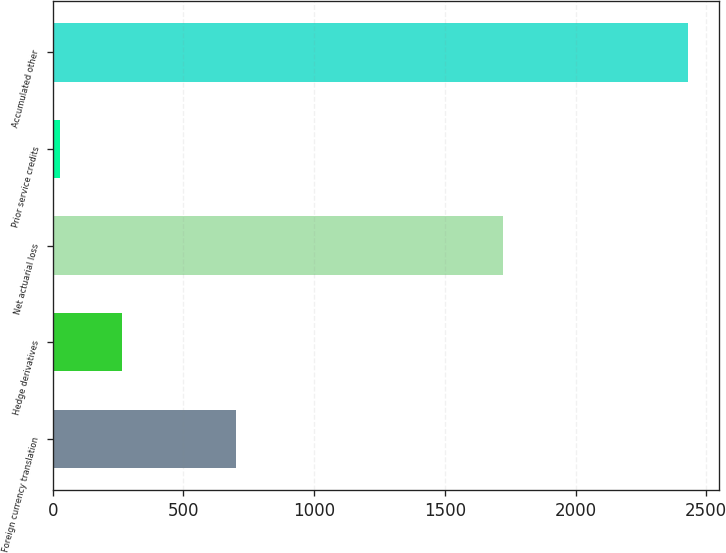<chart> <loc_0><loc_0><loc_500><loc_500><bar_chart><fcel>Foreign currency translation<fcel>Hedge derivatives<fcel>Net actuarial loss<fcel>Prior service credits<fcel>Accumulated other<nl><fcel>701.6<fcel>266.57<fcel>1723.6<fcel>26.3<fcel>2429<nl></chart> 